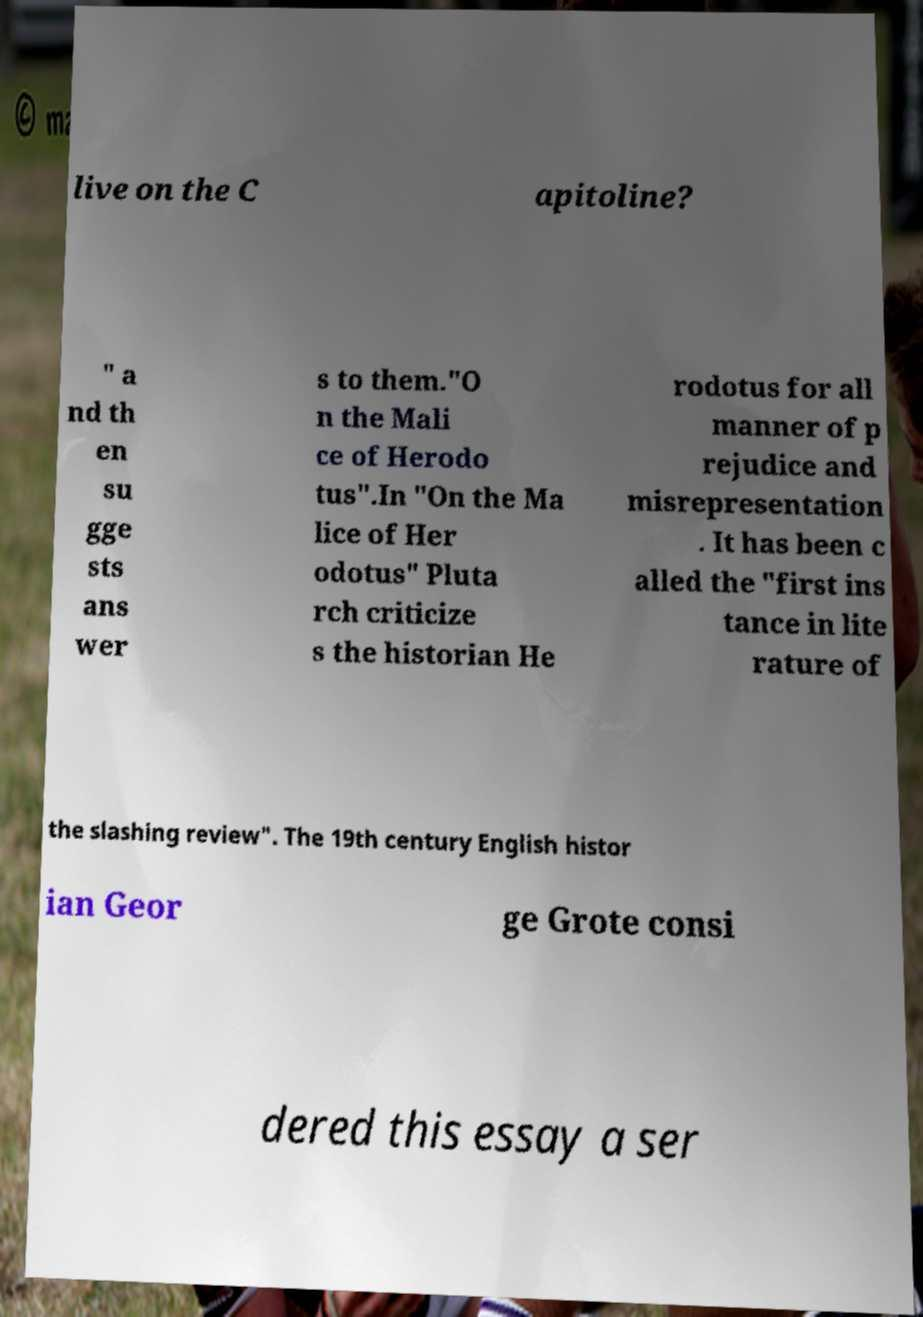For documentation purposes, I need the text within this image transcribed. Could you provide that? live on the C apitoline? " a nd th en su gge sts ans wer s to them."O n the Mali ce of Herodo tus".In "On the Ma lice of Her odotus" Pluta rch criticize s the historian He rodotus for all manner of p rejudice and misrepresentation . It has been c alled the "first ins tance in lite rature of the slashing review". The 19th century English histor ian Geor ge Grote consi dered this essay a ser 